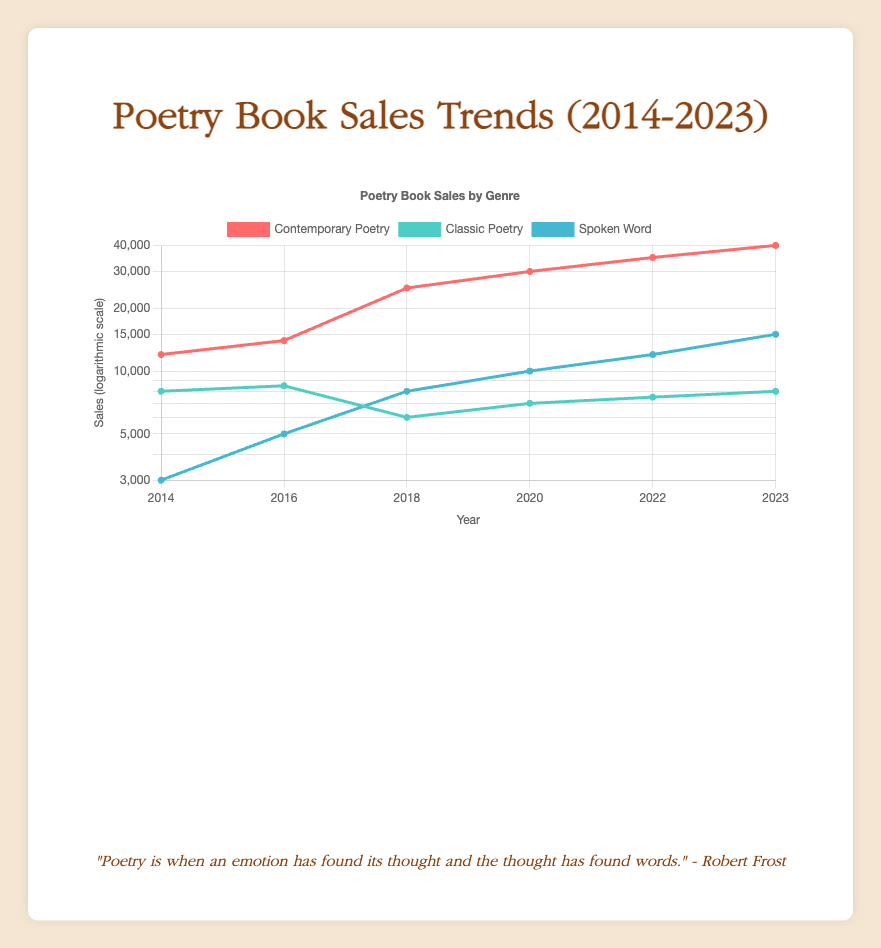What was the sales figure for Spoken Word poetry in 2020? According to the table, in 2020, the sales for Spoken Word poetry is listed as 10000.
Answer: 10000 Which genre had the highest sales in 2022? From the table, we can see that in 2022, Contemporary Poetry had sales of 35000, while Classic Poetry had 7500, and Spoken Word had 12000. The highest sales are for Contemporary Poetry.
Answer: Contemporary Poetry What is the total sales for Classic Poetry from 2014 to 2023? The sales figures for Classic Poetry are: 8000 (2014) + 8500 (2016) + 6000 (2018) + 7000 (2020) + 7500 (2022) + 8000 (2023). Summing these values gives 8000 + 8500 + 6000 + 7000 + 7500 + 8000 = 37500.
Answer: 37500 Did Spoken Word sales increase every year from 2014 to 2023? The sales figures for Spoken Word are 3000 (2014), 5000 (2016), 8000 (2018), 10000 (2020), 12000 (2022), and 15000 (2023). Each figure is higher than the previous year, confirming consistent yearly growth.
Answer: Yes What was the difference in sales for Contemporary Poetry between 2020 and 2022? The sales for Contemporary Poetry in 2020 was 30000 and in 2022 it was 35000. The difference is 35000 - 30000 = 5000.
Answer: 5000 What percentage of total sales in 2023 came from Spoken Word? For 2023, the total sales are 40000 (Contemporary Poetry) + 8000 (Classic Poetry) + 15000 (Spoken Word) = 63000. Spoken Word sales are 15000, so the percentage is (15000 / 63000) * 100 ≈ 23.81%.
Answer: 23.81% Which genre consistently had the lowest sales throughout the decade? Evaluating the sales figures for each genre across the years, Classic Poetry had the lowest sales where the highest sales were only 8500 in 2016, and it never surpassed that compared to other genres that had significantly higher sales.
Answer: Classic Poetry How do Contemporary Poetry sales in 2023 compare to its sales in 2014? In 2023, sales for Contemporary Poetry are 40000, while in 2014 they were 12000. The increase is 40000 - 12000 = 28000, indicating a significant rise over the decade.
Answer: 28000 